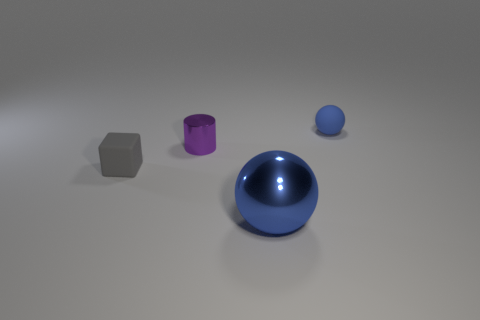Add 1 big purple rubber balls. How many objects exist? 5 Subtract all blocks. How many objects are left? 3 Add 4 big brown metallic cubes. How many big brown metallic cubes exist? 4 Subtract 0 brown cubes. How many objects are left? 4 Subtract all blue cylinders. Subtract all cyan cubes. How many cylinders are left? 1 Subtract all blue objects. Subtract all tiny purple objects. How many objects are left? 1 Add 2 small gray rubber cubes. How many small gray rubber cubes are left? 3 